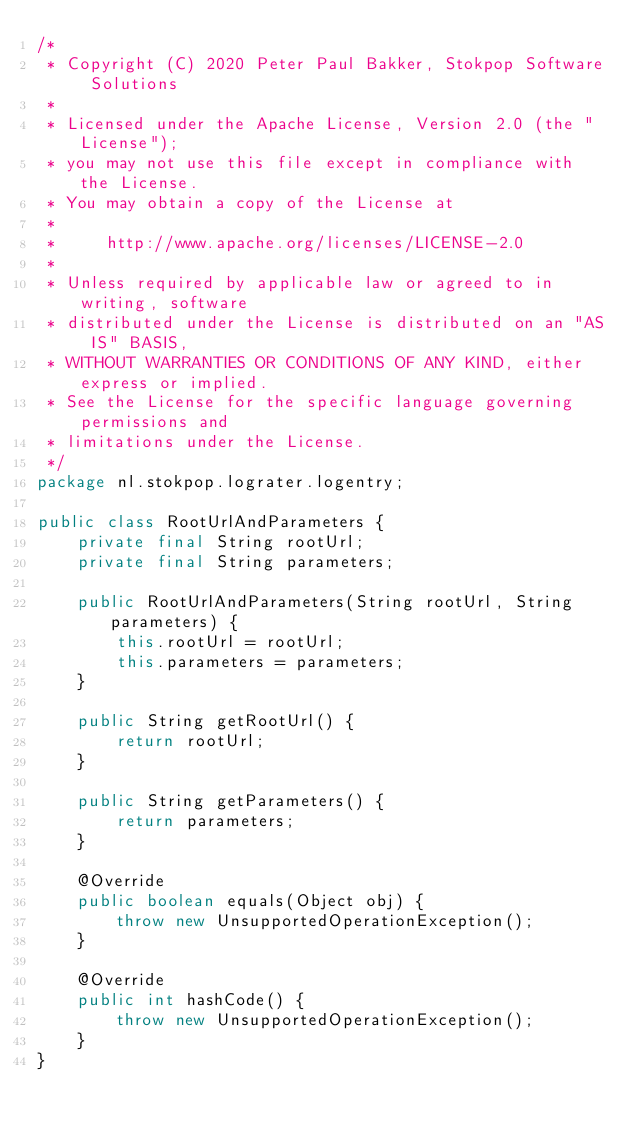<code> <loc_0><loc_0><loc_500><loc_500><_Java_>/*
 * Copyright (C) 2020 Peter Paul Bakker, Stokpop Software Solutions
 *
 * Licensed under the Apache License, Version 2.0 (the "License");
 * you may not use this file except in compliance with the License.
 * You may obtain a copy of the License at
 *
 *     http://www.apache.org/licenses/LICENSE-2.0
 *
 * Unless required by applicable law or agreed to in writing, software
 * distributed under the License is distributed on an "AS IS" BASIS,
 * WITHOUT WARRANTIES OR CONDITIONS OF ANY KIND, either express or implied.
 * See the License for the specific language governing permissions and
 * limitations under the License.
 */
package nl.stokpop.lograter.logentry;

public class RootUrlAndParameters {
    private final String rootUrl;
    private final String parameters;

    public RootUrlAndParameters(String rootUrl, String parameters) {
        this.rootUrl = rootUrl;
        this.parameters = parameters;
    }

    public String getRootUrl() {
        return rootUrl;
    }

    public String getParameters() {
        return parameters;
    }

    @Override
    public boolean equals(Object obj) {
        throw new UnsupportedOperationException();
    }

    @Override
    public int hashCode() {
        throw new UnsupportedOperationException();
    }
}
</code> 